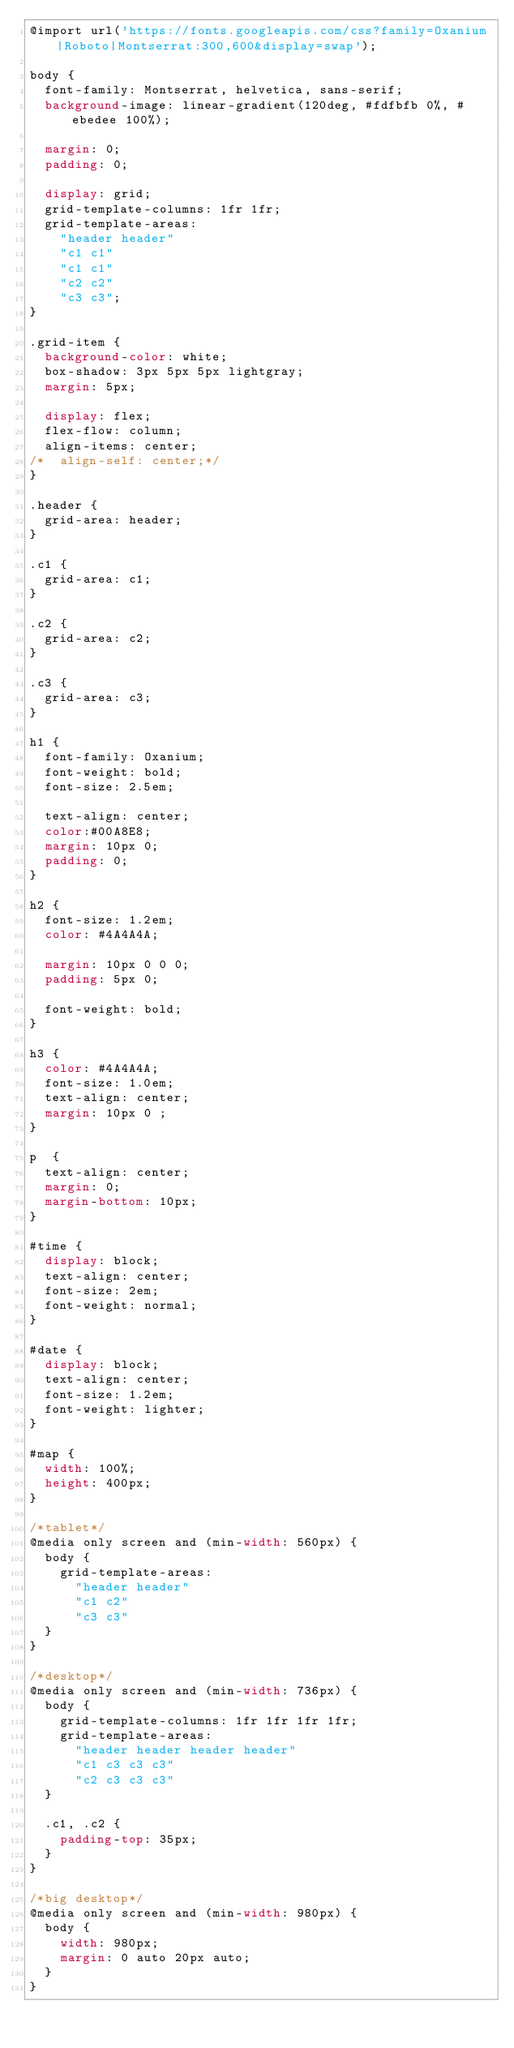<code> <loc_0><loc_0><loc_500><loc_500><_CSS_>@import url('https://fonts.googleapis.com/css?family=Oxanium|Roboto|Montserrat:300,600&display=swap');

body { 
	font-family: Montserrat, helvetica, sans-serif;
	background-image: linear-gradient(120deg, #fdfbfb 0%, #ebedee 100%);

	margin: 0; 
	padding: 0; 
	
	display: grid;
	grid-template-columns: 1fr 1fr;
	grid-template-areas: 
		"header header"
		"c1 c1"
		"c1 c1"
		"c2 c2"
		"c3 c3";
}

.grid-item {
	background-color: white;
	box-shadow: 3px 5px 5px lightgray;
	margin: 5px;
	
	display: flex;
	flex-flow: column;
	align-items: center;
/*	align-self: center;*/
}

.header {
	grid-area: header;
}

.c1 {
	grid-area: c1;
}

.c2 {
	grid-area: c2;
}

.c3 {
	grid-area: c3;
}

h1 {
	font-family: Oxanium;
	font-weight: bold;
	font-size: 2.5em;
	
	text-align: center;
	color:#00A8E8;
	margin: 10px 0;
	padding: 0;
}

h2 {
	font-size: 1.2em;
	color: #4A4A4A;
	
	margin: 10px 0 0 0;
	padding: 5px 0;
	
	font-weight: bold;
}

h3 {
	color: #4A4A4A;
	font-size: 1.0em; 
	text-align: center;	
	margin: 10px 0 ;
}

p  {
	text-align: center;
	margin: 0;
	margin-bottom: 10px;
}

#time {
	display: block;
	text-align: center;
	font-size: 2em;
	font-weight: normal;
}

#date {
	display: block;
	text-align: center;
	font-size: 1.2em;
	font-weight: lighter;
}

#map {
	width: 100%;
	height: 400px;
}

/*tablet*/
@media only screen and (min-width: 560px) {
	body {
		grid-template-areas: 
			"header header"
			"c1 c2"
			"c3 c3"
	}
}

/*desktop*/
@media only screen and (min-width: 736px) {
	body {
		grid-template-columns: 1fr 1fr 1fr 1fr;
		grid-template-areas: 
			"header header header header"
			"c1 c3 c3 c3"
			"c2 c3 c3 c3"
	}
	
	.c1, .c2 {
		padding-top: 35px;
	}
}

/*big desktop*/
@media only screen and (min-width: 980px) {
	body {
		width: 980px;
		margin: 0 auto 20px auto;
	}
}</code> 